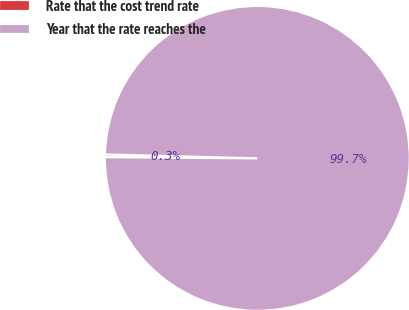<chart> <loc_0><loc_0><loc_500><loc_500><pie_chart><fcel>Rate that the cost trend rate<fcel>Year that the rate reaches the<nl><fcel>0.29%<fcel>99.71%<nl></chart> 